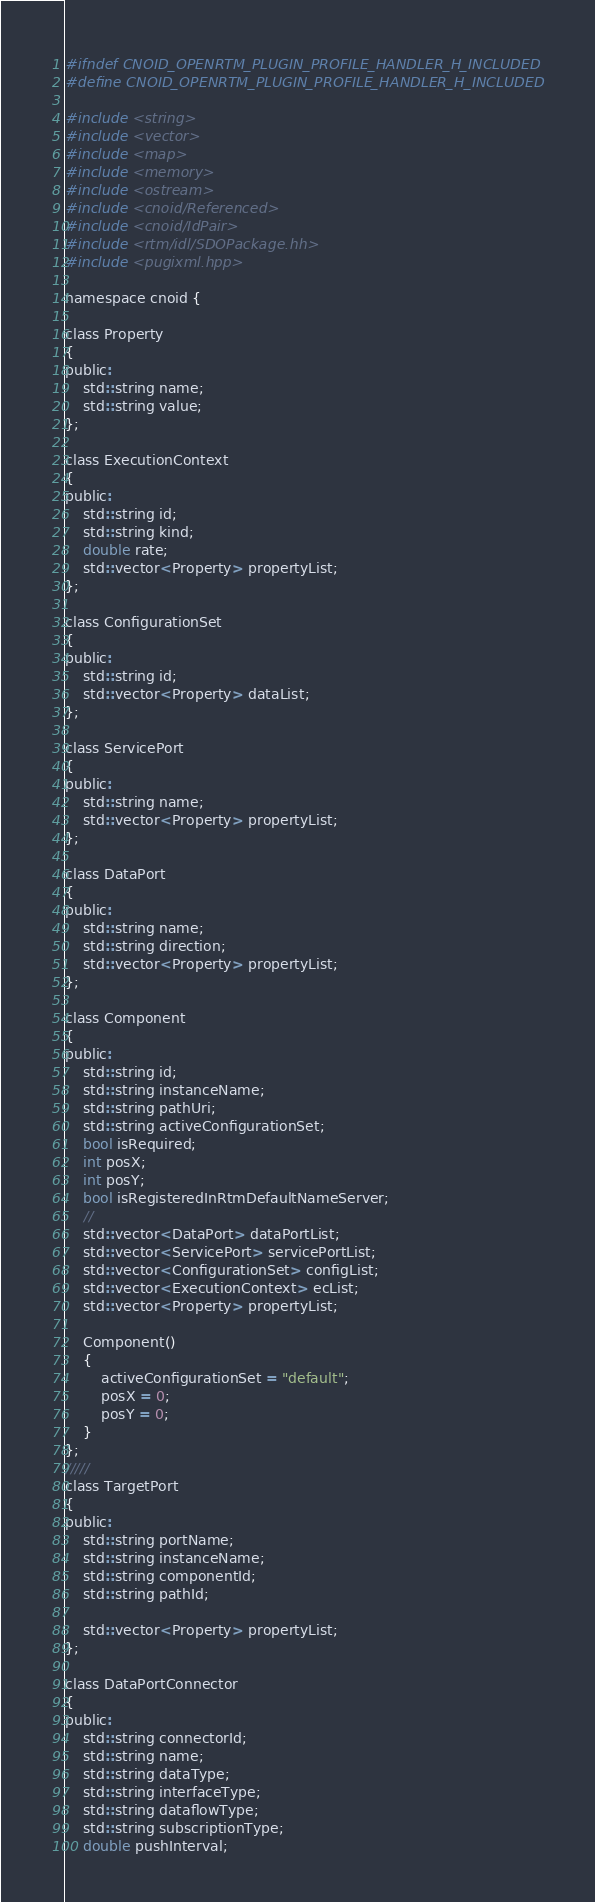Convert code to text. <code><loc_0><loc_0><loc_500><loc_500><_C_>#ifndef CNOID_OPENRTM_PLUGIN_PROFILE_HANDLER_H_INCLUDED
#define CNOID_OPENRTM_PLUGIN_PROFILE_HANDLER_H_INCLUDED

#include <string>
#include <vector>
#include <map>
#include <memory>
#include <ostream>
#include <cnoid/Referenced>
#include <cnoid/IdPair>
#include <rtm/idl/SDOPackage.hh>
#include <pugixml.hpp>

namespace cnoid {

class Property
{
public:
    std::string name;
    std::string value;
};

class ExecutionContext
{
public:
    std::string id;
    std::string kind;
    double rate;
    std::vector<Property> propertyList;
};

class ConfigurationSet
{
public:
    std::string id;
    std::vector<Property> dataList;
};

class ServicePort
{
public:
    std::string name;
    std::vector<Property> propertyList;
};

class DataPort
{
public:
    std::string name;
    std::string direction;
    std::vector<Property> propertyList;
};

class Component
{
public:
    std::string id;
    std::string instanceName;
    std::string pathUri;
    std::string activeConfigurationSet;
    bool isRequired;
    int posX;
    int posY;
    bool isRegisteredInRtmDefaultNameServer;
    //
    std::vector<DataPort> dataPortList;
    std::vector<ServicePort> servicePortList;
    std::vector<ConfigurationSet> configList;
    std::vector<ExecutionContext> ecList;
    std::vector<Property> propertyList;

    Component()
    {
        activeConfigurationSet = "default";
        posX = 0;
        posY = 0;
    }
};
/////
class TargetPort
{
public:
    std::string portName;
    std::string instanceName;
    std::string componentId;
    std::string pathId;

    std::vector<Property> propertyList;
};

class DataPortConnector
{
public:
    std::string connectorId;
    std::string name;
    std::string dataType;
    std::string interfaceType;
    std::string dataflowType;
    std::string subscriptionType;
    double pushInterval;</code> 